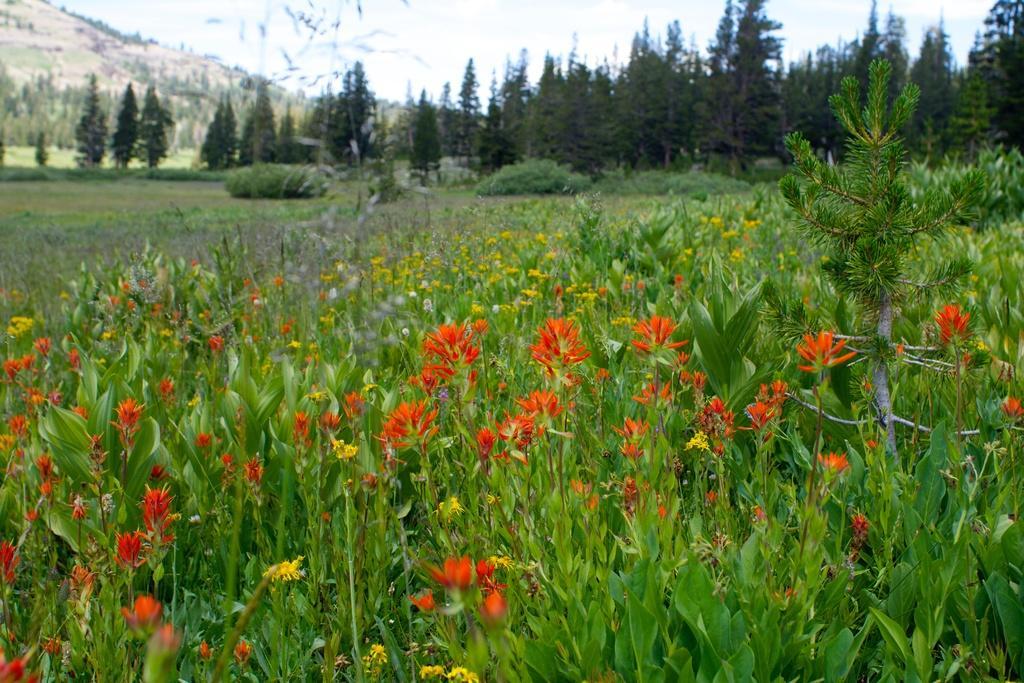How would you summarize this image in a sentence or two? These all are the flower plants. In the left side it is a hill. 